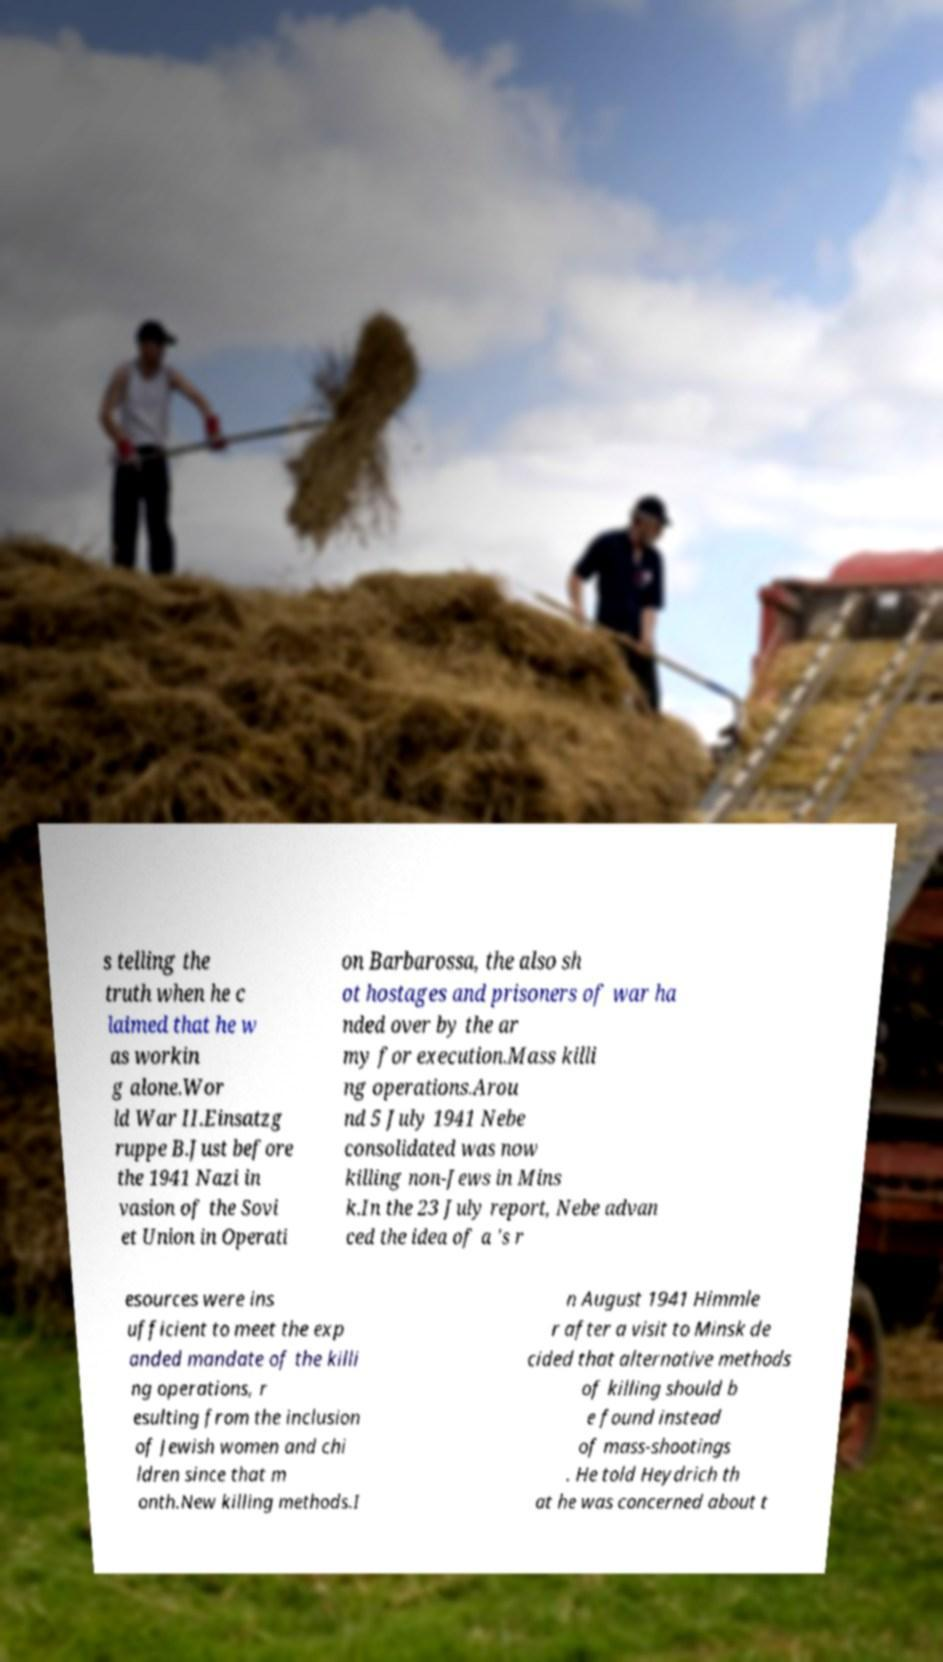There's text embedded in this image that I need extracted. Can you transcribe it verbatim? s telling the truth when he c laimed that he w as workin g alone.Wor ld War II.Einsatzg ruppe B.Just before the 1941 Nazi in vasion of the Sovi et Union in Operati on Barbarossa, the also sh ot hostages and prisoners of war ha nded over by the ar my for execution.Mass killi ng operations.Arou nd 5 July 1941 Nebe consolidated was now killing non-Jews in Mins k.In the 23 July report, Nebe advan ced the idea of a 's r esources were ins ufficient to meet the exp anded mandate of the killi ng operations, r esulting from the inclusion of Jewish women and chi ldren since that m onth.New killing methods.I n August 1941 Himmle r after a visit to Minsk de cided that alternative methods of killing should b e found instead of mass-shootings . He told Heydrich th at he was concerned about t 